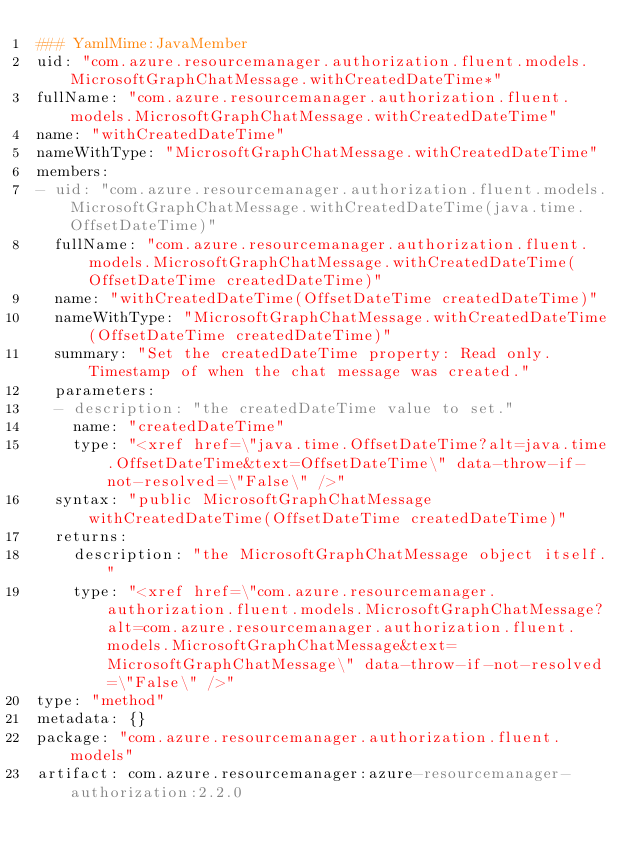<code> <loc_0><loc_0><loc_500><loc_500><_YAML_>### YamlMime:JavaMember
uid: "com.azure.resourcemanager.authorization.fluent.models.MicrosoftGraphChatMessage.withCreatedDateTime*"
fullName: "com.azure.resourcemanager.authorization.fluent.models.MicrosoftGraphChatMessage.withCreatedDateTime"
name: "withCreatedDateTime"
nameWithType: "MicrosoftGraphChatMessage.withCreatedDateTime"
members:
- uid: "com.azure.resourcemanager.authorization.fluent.models.MicrosoftGraphChatMessage.withCreatedDateTime(java.time.OffsetDateTime)"
  fullName: "com.azure.resourcemanager.authorization.fluent.models.MicrosoftGraphChatMessage.withCreatedDateTime(OffsetDateTime createdDateTime)"
  name: "withCreatedDateTime(OffsetDateTime createdDateTime)"
  nameWithType: "MicrosoftGraphChatMessage.withCreatedDateTime(OffsetDateTime createdDateTime)"
  summary: "Set the createdDateTime property: Read only. Timestamp of when the chat message was created."
  parameters:
  - description: "the createdDateTime value to set."
    name: "createdDateTime"
    type: "<xref href=\"java.time.OffsetDateTime?alt=java.time.OffsetDateTime&text=OffsetDateTime\" data-throw-if-not-resolved=\"False\" />"
  syntax: "public MicrosoftGraphChatMessage withCreatedDateTime(OffsetDateTime createdDateTime)"
  returns:
    description: "the MicrosoftGraphChatMessage object itself."
    type: "<xref href=\"com.azure.resourcemanager.authorization.fluent.models.MicrosoftGraphChatMessage?alt=com.azure.resourcemanager.authorization.fluent.models.MicrosoftGraphChatMessage&text=MicrosoftGraphChatMessage\" data-throw-if-not-resolved=\"False\" />"
type: "method"
metadata: {}
package: "com.azure.resourcemanager.authorization.fluent.models"
artifact: com.azure.resourcemanager:azure-resourcemanager-authorization:2.2.0
</code> 